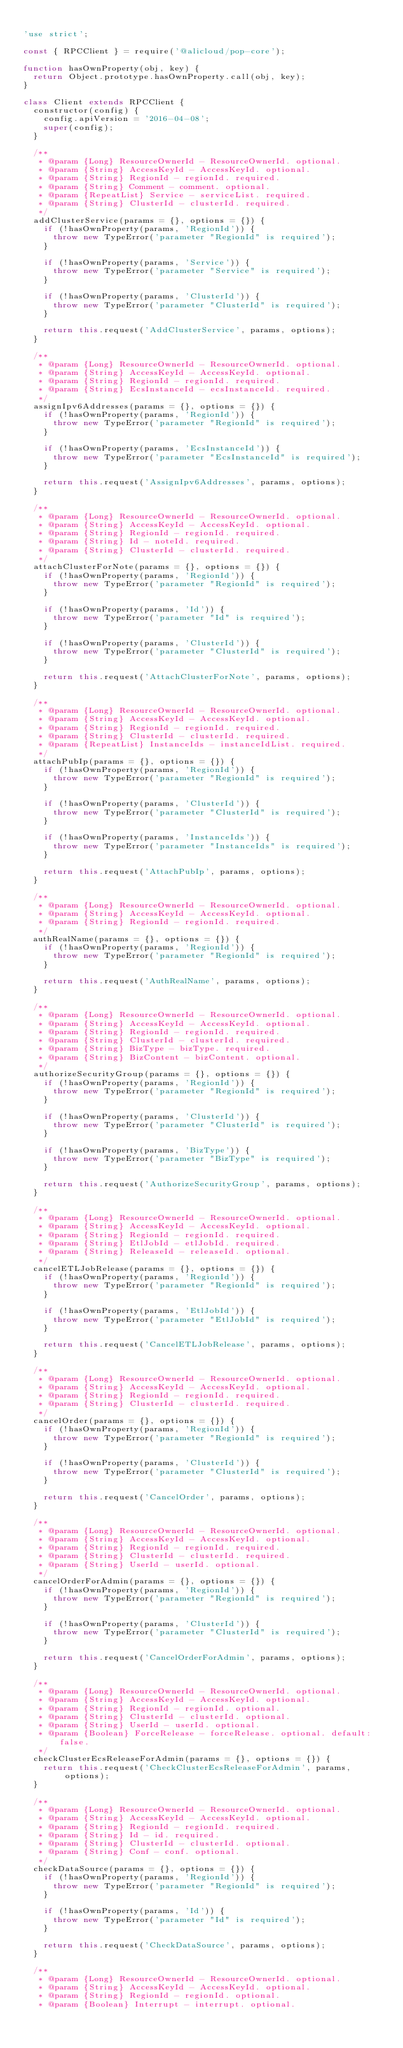<code> <loc_0><loc_0><loc_500><loc_500><_JavaScript_>
'use strict';

const { RPCClient } = require('@alicloud/pop-core');

function hasOwnProperty(obj, key) {
  return Object.prototype.hasOwnProperty.call(obj, key);
}

class Client extends RPCClient {
  constructor(config) {
    config.apiVersion = '2016-04-08';
    super(config);
  }

  /**
   * @param {Long} ResourceOwnerId - ResourceOwnerId. optional.
   * @param {String} AccessKeyId - AccessKeyId. optional.
   * @param {String} RegionId - regionId. required.
   * @param {String} Comment - comment. optional.
   * @param {RepeatList} Service - serviceList. required.
   * @param {String} ClusterId - clusterId. required.
   */
  addClusterService(params = {}, options = {}) {
    if (!hasOwnProperty(params, 'RegionId')) {
      throw new TypeError('parameter "RegionId" is required');
    }

    if (!hasOwnProperty(params, 'Service')) {
      throw new TypeError('parameter "Service" is required');
    }

    if (!hasOwnProperty(params, 'ClusterId')) {
      throw new TypeError('parameter "ClusterId" is required');
    }

    return this.request('AddClusterService', params, options);
  }

  /**
   * @param {Long} ResourceOwnerId - ResourceOwnerId. optional.
   * @param {String} AccessKeyId - AccessKeyId. optional.
   * @param {String} RegionId - regionId. required.
   * @param {String} EcsInstanceId - ecsInstanceId. required.
   */
  assignIpv6Addresses(params = {}, options = {}) {
    if (!hasOwnProperty(params, 'RegionId')) {
      throw new TypeError('parameter "RegionId" is required');
    }

    if (!hasOwnProperty(params, 'EcsInstanceId')) {
      throw new TypeError('parameter "EcsInstanceId" is required');
    }

    return this.request('AssignIpv6Addresses', params, options);
  }

  /**
   * @param {Long} ResourceOwnerId - ResourceOwnerId. optional.
   * @param {String} AccessKeyId - AccessKeyId. optional.
   * @param {String} RegionId - regionId. required.
   * @param {String} Id - noteId. required.
   * @param {String} ClusterId - clusterId. required.
   */
  attachClusterForNote(params = {}, options = {}) {
    if (!hasOwnProperty(params, 'RegionId')) {
      throw new TypeError('parameter "RegionId" is required');
    }

    if (!hasOwnProperty(params, 'Id')) {
      throw new TypeError('parameter "Id" is required');
    }

    if (!hasOwnProperty(params, 'ClusterId')) {
      throw new TypeError('parameter "ClusterId" is required');
    }

    return this.request('AttachClusterForNote', params, options);
  }

  /**
   * @param {Long} ResourceOwnerId - ResourceOwnerId. optional.
   * @param {String} AccessKeyId - AccessKeyId. optional.
   * @param {String} RegionId - regionId. required.
   * @param {String} ClusterId - clusterId. required.
   * @param {RepeatList} InstanceIds - instanceIdList. required.
   */
  attachPubIp(params = {}, options = {}) {
    if (!hasOwnProperty(params, 'RegionId')) {
      throw new TypeError('parameter "RegionId" is required');
    }

    if (!hasOwnProperty(params, 'ClusterId')) {
      throw new TypeError('parameter "ClusterId" is required');
    }

    if (!hasOwnProperty(params, 'InstanceIds')) {
      throw new TypeError('parameter "InstanceIds" is required');
    }

    return this.request('AttachPubIp', params, options);
  }

  /**
   * @param {Long} ResourceOwnerId - ResourceOwnerId. optional.
   * @param {String} AccessKeyId - AccessKeyId. optional.
   * @param {String} RegionId - regionId. required.
   */
  authRealName(params = {}, options = {}) {
    if (!hasOwnProperty(params, 'RegionId')) {
      throw new TypeError('parameter "RegionId" is required');
    }

    return this.request('AuthRealName', params, options);
  }

  /**
   * @param {Long} ResourceOwnerId - ResourceOwnerId. optional.
   * @param {String} AccessKeyId - AccessKeyId. optional.
   * @param {String} RegionId - regionId. required.
   * @param {String} ClusterId - clusterId. required.
   * @param {String} BizType - bizType. required.
   * @param {String} BizContent - bizContent. optional.
   */
  authorizeSecurityGroup(params = {}, options = {}) {
    if (!hasOwnProperty(params, 'RegionId')) {
      throw new TypeError('parameter "RegionId" is required');
    }

    if (!hasOwnProperty(params, 'ClusterId')) {
      throw new TypeError('parameter "ClusterId" is required');
    }

    if (!hasOwnProperty(params, 'BizType')) {
      throw new TypeError('parameter "BizType" is required');
    }

    return this.request('AuthorizeSecurityGroup', params, options);
  }

  /**
   * @param {Long} ResourceOwnerId - ResourceOwnerId. optional.
   * @param {String} AccessKeyId - AccessKeyId. optional.
   * @param {String} RegionId - regionId. required.
   * @param {String} EtlJobId - etlJobId. required.
   * @param {String} ReleaseId - releaseId. optional.
   */
  cancelETLJobRelease(params = {}, options = {}) {
    if (!hasOwnProperty(params, 'RegionId')) {
      throw new TypeError('parameter "RegionId" is required');
    }

    if (!hasOwnProperty(params, 'EtlJobId')) {
      throw new TypeError('parameter "EtlJobId" is required');
    }

    return this.request('CancelETLJobRelease', params, options);
  }

  /**
   * @param {Long} ResourceOwnerId - ResourceOwnerId. optional.
   * @param {String} AccessKeyId - AccessKeyId. optional.
   * @param {String} RegionId - regionId. required.
   * @param {String} ClusterId - clusterId. required.
   */
  cancelOrder(params = {}, options = {}) {
    if (!hasOwnProperty(params, 'RegionId')) {
      throw new TypeError('parameter "RegionId" is required');
    }

    if (!hasOwnProperty(params, 'ClusterId')) {
      throw new TypeError('parameter "ClusterId" is required');
    }

    return this.request('CancelOrder', params, options);
  }

  /**
   * @param {Long} ResourceOwnerId - ResourceOwnerId. optional.
   * @param {String} AccessKeyId - AccessKeyId. optional.
   * @param {String} RegionId - regionId. required.
   * @param {String} ClusterId - clusterId. required.
   * @param {String} UserId - userId. optional.
   */
  cancelOrderForAdmin(params = {}, options = {}) {
    if (!hasOwnProperty(params, 'RegionId')) {
      throw new TypeError('parameter "RegionId" is required');
    }

    if (!hasOwnProperty(params, 'ClusterId')) {
      throw new TypeError('parameter "ClusterId" is required');
    }

    return this.request('CancelOrderForAdmin', params, options);
  }

  /**
   * @param {Long} ResourceOwnerId - ResourceOwnerId. optional.
   * @param {String} AccessKeyId - AccessKeyId. optional.
   * @param {String} RegionId - regionId. optional.
   * @param {String} ClusterId - clusterId. optional.
   * @param {String} UserId - userId. optional.
   * @param {Boolean} ForceRelease - forceRelease. optional. default: false.
   */
  checkClusterEcsReleaseForAdmin(params = {}, options = {}) {
    return this.request('CheckClusterEcsReleaseForAdmin', params, options);
  }

  /**
   * @param {Long} ResourceOwnerId - ResourceOwnerId. optional.
   * @param {String} AccessKeyId - AccessKeyId. optional.
   * @param {String} RegionId - regionId. required.
   * @param {String} Id - id. required.
   * @param {String} ClusterId - clusterId. optional.
   * @param {String} Conf - conf. optional.
   */
  checkDataSource(params = {}, options = {}) {
    if (!hasOwnProperty(params, 'RegionId')) {
      throw new TypeError('parameter "RegionId" is required');
    }

    if (!hasOwnProperty(params, 'Id')) {
      throw new TypeError('parameter "Id" is required');
    }

    return this.request('CheckDataSource', params, options);
  }

  /**
   * @param {Long} ResourceOwnerId - ResourceOwnerId. optional.
   * @param {String} AccessKeyId - AccessKeyId. optional.
   * @param {String} RegionId - regionId. optional.
   * @param {Boolean} Interrupt - interrupt. optional.</code> 